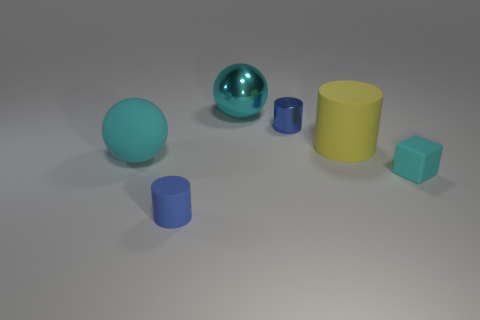Subtract all blue balls. How many blue cylinders are left? 2 Subtract all big matte cylinders. How many cylinders are left? 2 Add 1 brown cubes. How many objects exist? 7 Subtract 1 balls. How many balls are left? 1 Subtract all balls. How many objects are left? 4 Subtract all brown balls. Subtract all purple blocks. How many balls are left? 2 Subtract all matte things. Subtract all tiny cyan blocks. How many objects are left? 1 Add 6 large metallic objects. How many large metallic objects are left? 7 Add 2 yellow balls. How many yellow balls exist? 2 Subtract 1 cyan cubes. How many objects are left? 5 